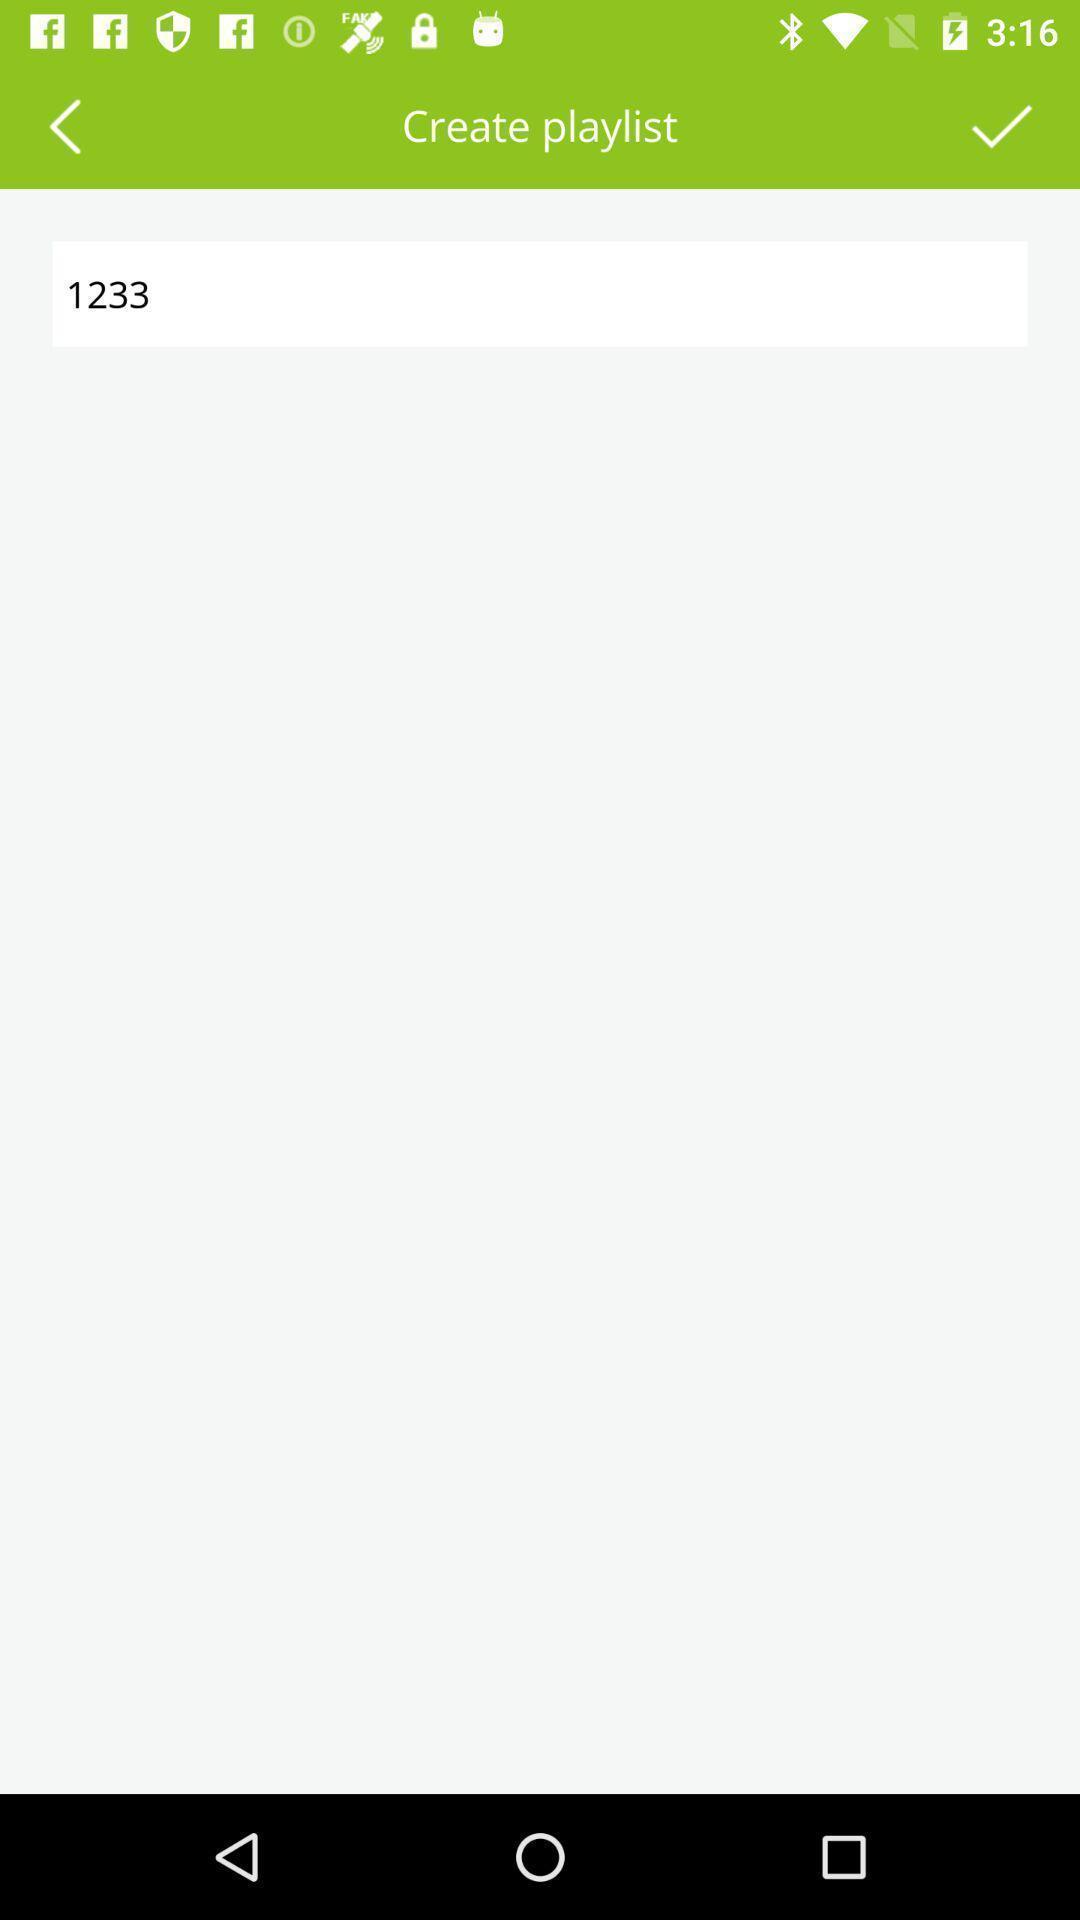Describe the content in this image. Plage displaying to create playlist of an music app. 